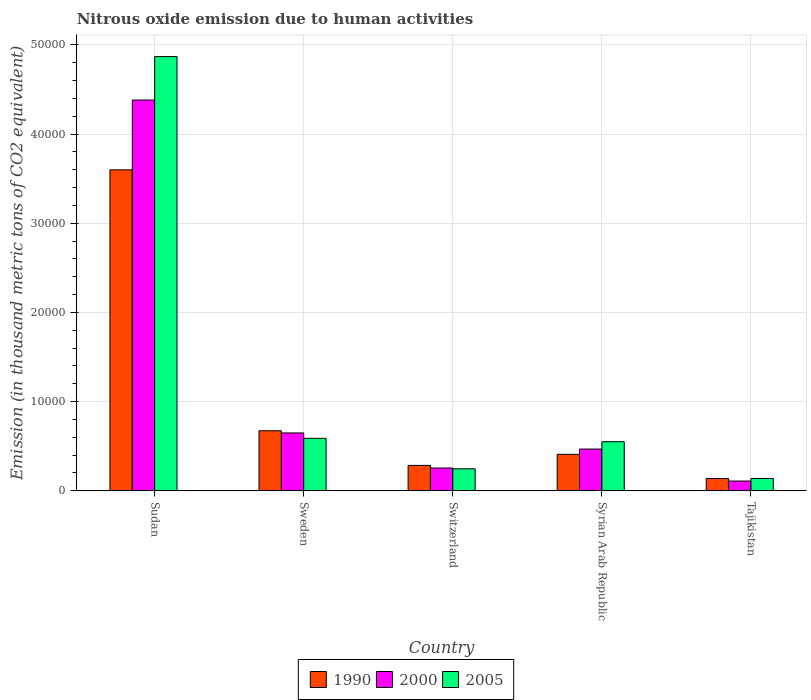Are the number of bars per tick equal to the number of legend labels?
Give a very brief answer. Yes. How many bars are there on the 4th tick from the left?
Offer a terse response. 3. What is the label of the 4th group of bars from the left?
Ensure brevity in your answer.  Syrian Arab Republic. What is the amount of nitrous oxide emitted in 2000 in Sweden?
Provide a short and direct response. 6484.9. Across all countries, what is the maximum amount of nitrous oxide emitted in 2000?
Offer a terse response. 4.38e+04. Across all countries, what is the minimum amount of nitrous oxide emitted in 2005?
Provide a succinct answer. 1381.6. In which country was the amount of nitrous oxide emitted in 2005 maximum?
Give a very brief answer. Sudan. In which country was the amount of nitrous oxide emitted in 1990 minimum?
Provide a succinct answer. Tajikistan. What is the total amount of nitrous oxide emitted in 1990 in the graph?
Your answer should be compact. 5.10e+04. What is the difference between the amount of nitrous oxide emitted in 1990 in Sudan and that in Tajikistan?
Offer a terse response. 3.46e+04. What is the difference between the amount of nitrous oxide emitted in 2000 in Syrian Arab Republic and the amount of nitrous oxide emitted in 1990 in Switzerland?
Ensure brevity in your answer.  1830.9. What is the average amount of nitrous oxide emitted in 1990 per country?
Ensure brevity in your answer.  1.02e+04. What is the difference between the amount of nitrous oxide emitted of/in 2000 and amount of nitrous oxide emitted of/in 1990 in Syrian Arab Republic?
Provide a succinct answer. 592.5. In how many countries, is the amount of nitrous oxide emitted in 2000 greater than 16000 thousand metric tons?
Provide a short and direct response. 1. What is the ratio of the amount of nitrous oxide emitted in 1990 in Sudan to that in Switzerland?
Your answer should be very brief. 12.64. What is the difference between the highest and the second highest amount of nitrous oxide emitted in 2005?
Keep it short and to the point. -4.28e+04. What is the difference between the highest and the lowest amount of nitrous oxide emitted in 2000?
Provide a short and direct response. 4.27e+04. Is the sum of the amount of nitrous oxide emitted in 1990 in Sweden and Syrian Arab Republic greater than the maximum amount of nitrous oxide emitted in 2000 across all countries?
Ensure brevity in your answer.  No. What does the 3rd bar from the left in Switzerland represents?
Give a very brief answer. 2005. Is it the case that in every country, the sum of the amount of nitrous oxide emitted in 1990 and amount of nitrous oxide emitted in 2005 is greater than the amount of nitrous oxide emitted in 2000?
Make the answer very short. Yes. How many bars are there?
Provide a short and direct response. 15. Are all the bars in the graph horizontal?
Offer a very short reply. No. What is the difference between two consecutive major ticks on the Y-axis?
Offer a very short reply. 10000. Does the graph contain any zero values?
Make the answer very short. No. Where does the legend appear in the graph?
Give a very brief answer. Bottom center. What is the title of the graph?
Ensure brevity in your answer.  Nitrous oxide emission due to human activities. Does "1978" appear as one of the legend labels in the graph?
Make the answer very short. No. What is the label or title of the Y-axis?
Ensure brevity in your answer.  Emission (in thousand metric tons of CO2 equivalent). What is the Emission (in thousand metric tons of CO2 equivalent) of 1990 in Sudan?
Your response must be concise. 3.60e+04. What is the Emission (in thousand metric tons of CO2 equivalent) of 2000 in Sudan?
Give a very brief answer. 4.38e+04. What is the Emission (in thousand metric tons of CO2 equivalent) of 2005 in Sudan?
Make the answer very short. 4.87e+04. What is the Emission (in thousand metric tons of CO2 equivalent) of 1990 in Sweden?
Give a very brief answer. 6731.4. What is the Emission (in thousand metric tons of CO2 equivalent) in 2000 in Sweden?
Offer a very short reply. 6484.9. What is the Emission (in thousand metric tons of CO2 equivalent) in 2005 in Sweden?
Ensure brevity in your answer.  5882.7. What is the Emission (in thousand metric tons of CO2 equivalent) of 1990 in Switzerland?
Give a very brief answer. 2846.4. What is the Emission (in thousand metric tons of CO2 equivalent) of 2000 in Switzerland?
Offer a very short reply. 2551.9. What is the Emission (in thousand metric tons of CO2 equivalent) in 2005 in Switzerland?
Your answer should be compact. 2463.6. What is the Emission (in thousand metric tons of CO2 equivalent) in 1990 in Syrian Arab Republic?
Ensure brevity in your answer.  4084.8. What is the Emission (in thousand metric tons of CO2 equivalent) in 2000 in Syrian Arab Republic?
Ensure brevity in your answer.  4677.3. What is the Emission (in thousand metric tons of CO2 equivalent) in 2005 in Syrian Arab Republic?
Your response must be concise. 5502.2. What is the Emission (in thousand metric tons of CO2 equivalent) of 1990 in Tajikistan?
Ensure brevity in your answer.  1377.2. What is the Emission (in thousand metric tons of CO2 equivalent) of 2000 in Tajikistan?
Provide a short and direct response. 1092.8. What is the Emission (in thousand metric tons of CO2 equivalent) in 2005 in Tajikistan?
Offer a terse response. 1381.6. Across all countries, what is the maximum Emission (in thousand metric tons of CO2 equivalent) in 1990?
Make the answer very short. 3.60e+04. Across all countries, what is the maximum Emission (in thousand metric tons of CO2 equivalent) of 2000?
Offer a very short reply. 4.38e+04. Across all countries, what is the maximum Emission (in thousand metric tons of CO2 equivalent) of 2005?
Your answer should be compact. 4.87e+04. Across all countries, what is the minimum Emission (in thousand metric tons of CO2 equivalent) of 1990?
Provide a succinct answer. 1377.2. Across all countries, what is the minimum Emission (in thousand metric tons of CO2 equivalent) of 2000?
Ensure brevity in your answer.  1092.8. Across all countries, what is the minimum Emission (in thousand metric tons of CO2 equivalent) in 2005?
Keep it short and to the point. 1381.6. What is the total Emission (in thousand metric tons of CO2 equivalent) in 1990 in the graph?
Ensure brevity in your answer.  5.10e+04. What is the total Emission (in thousand metric tons of CO2 equivalent) of 2000 in the graph?
Your answer should be very brief. 5.86e+04. What is the total Emission (in thousand metric tons of CO2 equivalent) in 2005 in the graph?
Offer a terse response. 6.39e+04. What is the difference between the Emission (in thousand metric tons of CO2 equivalent) in 1990 in Sudan and that in Sweden?
Offer a very short reply. 2.93e+04. What is the difference between the Emission (in thousand metric tons of CO2 equivalent) in 2000 in Sudan and that in Sweden?
Your response must be concise. 3.73e+04. What is the difference between the Emission (in thousand metric tons of CO2 equivalent) of 2005 in Sudan and that in Sweden?
Offer a very short reply. 4.28e+04. What is the difference between the Emission (in thousand metric tons of CO2 equivalent) of 1990 in Sudan and that in Switzerland?
Provide a succinct answer. 3.31e+04. What is the difference between the Emission (in thousand metric tons of CO2 equivalent) in 2000 in Sudan and that in Switzerland?
Offer a very short reply. 4.13e+04. What is the difference between the Emission (in thousand metric tons of CO2 equivalent) of 2005 in Sudan and that in Switzerland?
Keep it short and to the point. 4.62e+04. What is the difference between the Emission (in thousand metric tons of CO2 equivalent) of 1990 in Sudan and that in Syrian Arab Republic?
Keep it short and to the point. 3.19e+04. What is the difference between the Emission (in thousand metric tons of CO2 equivalent) of 2000 in Sudan and that in Syrian Arab Republic?
Give a very brief answer. 3.91e+04. What is the difference between the Emission (in thousand metric tons of CO2 equivalent) of 2005 in Sudan and that in Syrian Arab Republic?
Make the answer very short. 4.32e+04. What is the difference between the Emission (in thousand metric tons of CO2 equivalent) in 1990 in Sudan and that in Tajikistan?
Ensure brevity in your answer.  3.46e+04. What is the difference between the Emission (in thousand metric tons of CO2 equivalent) in 2000 in Sudan and that in Tajikistan?
Ensure brevity in your answer.  4.27e+04. What is the difference between the Emission (in thousand metric tons of CO2 equivalent) in 2005 in Sudan and that in Tajikistan?
Provide a succinct answer. 4.73e+04. What is the difference between the Emission (in thousand metric tons of CO2 equivalent) of 1990 in Sweden and that in Switzerland?
Your answer should be very brief. 3885. What is the difference between the Emission (in thousand metric tons of CO2 equivalent) of 2000 in Sweden and that in Switzerland?
Give a very brief answer. 3933. What is the difference between the Emission (in thousand metric tons of CO2 equivalent) of 2005 in Sweden and that in Switzerland?
Your answer should be very brief. 3419.1. What is the difference between the Emission (in thousand metric tons of CO2 equivalent) in 1990 in Sweden and that in Syrian Arab Republic?
Provide a short and direct response. 2646.6. What is the difference between the Emission (in thousand metric tons of CO2 equivalent) in 2000 in Sweden and that in Syrian Arab Republic?
Provide a succinct answer. 1807.6. What is the difference between the Emission (in thousand metric tons of CO2 equivalent) in 2005 in Sweden and that in Syrian Arab Republic?
Offer a very short reply. 380.5. What is the difference between the Emission (in thousand metric tons of CO2 equivalent) in 1990 in Sweden and that in Tajikistan?
Keep it short and to the point. 5354.2. What is the difference between the Emission (in thousand metric tons of CO2 equivalent) of 2000 in Sweden and that in Tajikistan?
Offer a terse response. 5392.1. What is the difference between the Emission (in thousand metric tons of CO2 equivalent) in 2005 in Sweden and that in Tajikistan?
Make the answer very short. 4501.1. What is the difference between the Emission (in thousand metric tons of CO2 equivalent) of 1990 in Switzerland and that in Syrian Arab Republic?
Offer a terse response. -1238.4. What is the difference between the Emission (in thousand metric tons of CO2 equivalent) in 2000 in Switzerland and that in Syrian Arab Republic?
Give a very brief answer. -2125.4. What is the difference between the Emission (in thousand metric tons of CO2 equivalent) of 2005 in Switzerland and that in Syrian Arab Republic?
Give a very brief answer. -3038.6. What is the difference between the Emission (in thousand metric tons of CO2 equivalent) in 1990 in Switzerland and that in Tajikistan?
Give a very brief answer. 1469.2. What is the difference between the Emission (in thousand metric tons of CO2 equivalent) of 2000 in Switzerland and that in Tajikistan?
Your answer should be very brief. 1459.1. What is the difference between the Emission (in thousand metric tons of CO2 equivalent) in 2005 in Switzerland and that in Tajikistan?
Provide a succinct answer. 1082. What is the difference between the Emission (in thousand metric tons of CO2 equivalent) in 1990 in Syrian Arab Republic and that in Tajikistan?
Your answer should be compact. 2707.6. What is the difference between the Emission (in thousand metric tons of CO2 equivalent) of 2000 in Syrian Arab Republic and that in Tajikistan?
Offer a very short reply. 3584.5. What is the difference between the Emission (in thousand metric tons of CO2 equivalent) in 2005 in Syrian Arab Republic and that in Tajikistan?
Ensure brevity in your answer.  4120.6. What is the difference between the Emission (in thousand metric tons of CO2 equivalent) in 1990 in Sudan and the Emission (in thousand metric tons of CO2 equivalent) in 2000 in Sweden?
Provide a short and direct response. 2.95e+04. What is the difference between the Emission (in thousand metric tons of CO2 equivalent) in 1990 in Sudan and the Emission (in thousand metric tons of CO2 equivalent) in 2005 in Sweden?
Make the answer very short. 3.01e+04. What is the difference between the Emission (in thousand metric tons of CO2 equivalent) of 2000 in Sudan and the Emission (in thousand metric tons of CO2 equivalent) of 2005 in Sweden?
Make the answer very short. 3.79e+04. What is the difference between the Emission (in thousand metric tons of CO2 equivalent) of 1990 in Sudan and the Emission (in thousand metric tons of CO2 equivalent) of 2000 in Switzerland?
Provide a short and direct response. 3.34e+04. What is the difference between the Emission (in thousand metric tons of CO2 equivalent) in 1990 in Sudan and the Emission (in thousand metric tons of CO2 equivalent) in 2005 in Switzerland?
Give a very brief answer. 3.35e+04. What is the difference between the Emission (in thousand metric tons of CO2 equivalent) of 2000 in Sudan and the Emission (in thousand metric tons of CO2 equivalent) of 2005 in Switzerland?
Your answer should be compact. 4.13e+04. What is the difference between the Emission (in thousand metric tons of CO2 equivalent) in 1990 in Sudan and the Emission (in thousand metric tons of CO2 equivalent) in 2000 in Syrian Arab Republic?
Offer a terse response. 3.13e+04. What is the difference between the Emission (in thousand metric tons of CO2 equivalent) in 1990 in Sudan and the Emission (in thousand metric tons of CO2 equivalent) in 2005 in Syrian Arab Republic?
Your answer should be compact. 3.05e+04. What is the difference between the Emission (in thousand metric tons of CO2 equivalent) of 2000 in Sudan and the Emission (in thousand metric tons of CO2 equivalent) of 2005 in Syrian Arab Republic?
Offer a very short reply. 3.83e+04. What is the difference between the Emission (in thousand metric tons of CO2 equivalent) of 1990 in Sudan and the Emission (in thousand metric tons of CO2 equivalent) of 2000 in Tajikistan?
Make the answer very short. 3.49e+04. What is the difference between the Emission (in thousand metric tons of CO2 equivalent) in 1990 in Sudan and the Emission (in thousand metric tons of CO2 equivalent) in 2005 in Tajikistan?
Give a very brief answer. 3.46e+04. What is the difference between the Emission (in thousand metric tons of CO2 equivalent) in 2000 in Sudan and the Emission (in thousand metric tons of CO2 equivalent) in 2005 in Tajikistan?
Your answer should be compact. 4.24e+04. What is the difference between the Emission (in thousand metric tons of CO2 equivalent) in 1990 in Sweden and the Emission (in thousand metric tons of CO2 equivalent) in 2000 in Switzerland?
Keep it short and to the point. 4179.5. What is the difference between the Emission (in thousand metric tons of CO2 equivalent) of 1990 in Sweden and the Emission (in thousand metric tons of CO2 equivalent) of 2005 in Switzerland?
Your response must be concise. 4267.8. What is the difference between the Emission (in thousand metric tons of CO2 equivalent) of 2000 in Sweden and the Emission (in thousand metric tons of CO2 equivalent) of 2005 in Switzerland?
Offer a very short reply. 4021.3. What is the difference between the Emission (in thousand metric tons of CO2 equivalent) in 1990 in Sweden and the Emission (in thousand metric tons of CO2 equivalent) in 2000 in Syrian Arab Republic?
Provide a short and direct response. 2054.1. What is the difference between the Emission (in thousand metric tons of CO2 equivalent) in 1990 in Sweden and the Emission (in thousand metric tons of CO2 equivalent) in 2005 in Syrian Arab Republic?
Your answer should be very brief. 1229.2. What is the difference between the Emission (in thousand metric tons of CO2 equivalent) in 2000 in Sweden and the Emission (in thousand metric tons of CO2 equivalent) in 2005 in Syrian Arab Republic?
Keep it short and to the point. 982.7. What is the difference between the Emission (in thousand metric tons of CO2 equivalent) in 1990 in Sweden and the Emission (in thousand metric tons of CO2 equivalent) in 2000 in Tajikistan?
Keep it short and to the point. 5638.6. What is the difference between the Emission (in thousand metric tons of CO2 equivalent) in 1990 in Sweden and the Emission (in thousand metric tons of CO2 equivalent) in 2005 in Tajikistan?
Your answer should be compact. 5349.8. What is the difference between the Emission (in thousand metric tons of CO2 equivalent) in 2000 in Sweden and the Emission (in thousand metric tons of CO2 equivalent) in 2005 in Tajikistan?
Your answer should be compact. 5103.3. What is the difference between the Emission (in thousand metric tons of CO2 equivalent) in 1990 in Switzerland and the Emission (in thousand metric tons of CO2 equivalent) in 2000 in Syrian Arab Republic?
Ensure brevity in your answer.  -1830.9. What is the difference between the Emission (in thousand metric tons of CO2 equivalent) in 1990 in Switzerland and the Emission (in thousand metric tons of CO2 equivalent) in 2005 in Syrian Arab Republic?
Your response must be concise. -2655.8. What is the difference between the Emission (in thousand metric tons of CO2 equivalent) in 2000 in Switzerland and the Emission (in thousand metric tons of CO2 equivalent) in 2005 in Syrian Arab Republic?
Provide a short and direct response. -2950.3. What is the difference between the Emission (in thousand metric tons of CO2 equivalent) in 1990 in Switzerland and the Emission (in thousand metric tons of CO2 equivalent) in 2000 in Tajikistan?
Your answer should be compact. 1753.6. What is the difference between the Emission (in thousand metric tons of CO2 equivalent) in 1990 in Switzerland and the Emission (in thousand metric tons of CO2 equivalent) in 2005 in Tajikistan?
Provide a short and direct response. 1464.8. What is the difference between the Emission (in thousand metric tons of CO2 equivalent) of 2000 in Switzerland and the Emission (in thousand metric tons of CO2 equivalent) of 2005 in Tajikistan?
Keep it short and to the point. 1170.3. What is the difference between the Emission (in thousand metric tons of CO2 equivalent) in 1990 in Syrian Arab Republic and the Emission (in thousand metric tons of CO2 equivalent) in 2000 in Tajikistan?
Offer a terse response. 2992. What is the difference between the Emission (in thousand metric tons of CO2 equivalent) of 1990 in Syrian Arab Republic and the Emission (in thousand metric tons of CO2 equivalent) of 2005 in Tajikistan?
Your answer should be compact. 2703.2. What is the difference between the Emission (in thousand metric tons of CO2 equivalent) in 2000 in Syrian Arab Republic and the Emission (in thousand metric tons of CO2 equivalent) in 2005 in Tajikistan?
Offer a terse response. 3295.7. What is the average Emission (in thousand metric tons of CO2 equivalent) in 1990 per country?
Your response must be concise. 1.02e+04. What is the average Emission (in thousand metric tons of CO2 equivalent) of 2000 per country?
Provide a succinct answer. 1.17e+04. What is the average Emission (in thousand metric tons of CO2 equivalent) in 2005 per country?
Give a very brief answer. 1.28e+04. What is the difference between the Emission (in thousand metric tons of CO2 equivalent) of 1990 and Emission (in thousand metric tons of CO2 equivalent) of 2000 in Sudan?
Provide a short and direct response. -7827.3. What is the difference between the Emission (in thousand metric tons of CO2 equivalent) of 1990 and Emission (in thousand metric tons of CO2 equivalent) of 2005 in Sudan?
Your answer should be compact. -1.27e+04. What is the difference between the Emission (in thousand metric tons of CO2 equivalent) of 2000 and Emission (in thousand metric tons of CO2 equivalent) of 2005 in Sudan?
Your answer should be very brief. -4871.9. What is the difference between the Emission (in thousand metric tons of CO2 equivalent) in 1990 and Emission (in thousand metric tons of CO2 equivalent) in 2000 in Sweden?
Ensure brevity in your answer.  246.5. What is the difference between the Emission (in thousand metric tons of CO2 equivalent) of 1990 and Emission (in thousand metric tons of CO2 equivalent) of 2005 in Sweden?
Give a very brief answer. 848.7. What is the difference between the Emission (in thousand metric tons of CO2 equivalent) in 2000 and Emission (in thousand metric tons of CO2 equivalent) in 2005 in Sweden?
Offer a very short reply. 602.2. What is the difference between the Emission (in thousand metric tons of CO2 equivalent) of 1990 and Emission (in thousand metric tons of CO2 equivalent) of 2000 in Switzerland?
Ensure brevity in your answer.  294.5. What is the difference between the Emission (in thousand metric tons of CO2 equivalent) of 1990 and Emission (in thousand metric tons of CO2 equivalent) of 2005 in Switzerland?
Make the answer very short. 382.8. What is the difference between the Emission (in thousand metric tons of CO2 equivalent) in 2000 and Emission (in thousand metric tons of CO2 equivalent) in 2005 in Switzerland?
Keep it short and to the point. 88.3. What is the difference between the Emission (in thousand metric tons of CO2 equivalent) in 1990 and Emission (in thousand metric tons of CO2 equivalent) in 2000 in Syrian Arab Republic?
Your answer should be compact. -592.5. What is the difference between the Emission (in thousand metric tons of CO2 equivalent) in 1990 and Emission (in thousand metric tons of CO2 equivalent) in 2005 in Syrian Arab Republic?
Keep it short and to the point. -1417.4. What is the difference between the Emission (in thousand metric tons of CO2 equivalent) of 2000 and Emission (in thousand metric tons of CO2 equivalent) of 2005 in Syrian Arab Republic?
Give a very brief answer. -824.9. What is the difference between the Emission (in thousand metric tons of CO2 equivalent) in 1990 and Emission (in thousand metric tons of CO2 equivalent) in 2000 in Tajikistan?
Offer a terse response. 284.4. What is the difference between the Emission (in thousand metric tons of CO2 equivalent) in 1990 and Emission (in thousand metric tons of CO2 equivalent) in 2005 in Tajikistan?
Your answer should be very brief. -4.4. What is the difference between the Emission (in thousand metric tons of CO2 equivalent) in 2000 and Emission (in thousand metric tons of CO2 equivalent) in 2005 in Tajikistan?
Your response must be concise. -288.8. What is the ratio of the Emission (in thousand metric tons of CO2 equivalent) in 1990 in Sudan to that in Sweden?
Make the answer very short. 5.35. What is the ratio of the Emission (in thousand metric tons of CO2 equivalent) of 2000 in Sudan to that in Sweden?
Your answer should be compact. 6.76. What is the ratio of the Emission (in thousand metric tons of CO2 equivalent) of 2005 in Sudan to that in Sweden?
Provide a succinct answer. 8.28. What is the ratio of the Emission (in thousand metric tons of CO2 equivalent) in 1990 in Sudan to that in Switzerland?
Provide a short and direct response. 12.64. What is the ratio of the Emission (in thousand metric tons of CO2 equivalent) in 2000 in Sudan to that in Switzerland?
Make the answer very short. 17.17. What is the ratio of the Emission (in thousand metric tons of CO2 equivalent) of 2005 in Sudan to that in Switzerland?
Keep it short and to the point. 19.76. What is the ratio of the Emission (in thousand metric tons of CO2 equivalent) of 1990 in Sudan to that in Syrian Arab Republic?
Offer a terse response. 8.81. What is the ratio of the Emission (in thousand metric tons of CO2 equivalent) of 2000 in Sudan to that in Syrian Arab Republic?
Make the answer very short. 9.37. What is the ratio of the Emission (in thousand metric tons of CO2 equivalent) of 2005 in Sudan to that in Syrian Arab Republic?
Offer a terse response. 8.85. What is the ratio of the Emission (in thousand metric tons of CO2 equivalent) in 1990 in Sudan to that in Tajikistan?
Keep it short and to the point. 26.13. What is the ratio of the Emission (in thousand metric tons of CO2 equivalent) in 2000 in Sudan to that in Tajikistan?
Provide a succinct answer. 40.09. What is the ratio of the Emission (in thousand metric tons of CO2 equivalent) of 2005 in Sudan to that in Tajikistan?
Ensure brevity in your answer.  35.24. What is the ratio of the Emission (in thousand metric tons of CO2 equivalent) of 1990 in Sweden to that in Switzerland?
Provide a succinct answer. 2.36. What is the ratio of the Emission (in thousand metric tons of CO2 equivalent) in 2000 in Sweden to that in Switzerland?
Your response must be concise. 2.54. What is the ratio of the Emission (in thousand metric tons of CO2 equivalent) of 2005 in Sweden to that in Switzerland?
Provide a succinct answer. 2.39. What is the ratio of the Emission (in thousand metric tons of CO2 equivalent) of 1990 in Sweden to that in Syrian Arab Republic?
Your answer should be compact. 1.65. What is the ratio of the Emission (in thousand metric tons of CO2 equivalent) of 2000 in Sweden to that in Syrian Arab Republic?
Offer a very short reply. 1.39. What is the ratio of the Emission (in thousand metric tons of CO2 equivalent) of 2005 in Sweden to that in Syrian Arab Republic?
Keep it short and to the point. 1.07. What is the ratio of the Emission (in thousand metric tons of CO2 equivalent) in 1990 in Sweden to that in Tajikistan?
Keep it short and to the point. 4.89. What is the ratio of the Emission (in thousand metric tons of CO2 equivalent) in 2000 in Sweden to that in Tajikistan?
Your answer should be compact. 5.93. What is the ratio of the Emission (in thousand metric tons of CO2 equivalent) of 2005 in Sweden to that in Tajikistan?
Offer a terse response. 4.26. What is the ratio of the Emission (in thousand metric tons of CO2 equivalent) of 1990 in Switzerland to that in Syrian Arab Republic?
Offer a terse response. 0.7. What is the ratio of the Emission (in thousand metric tons of CO2 equivalent) of 2000 in Switzerland to that in Syrian Arab Republic?
Keep it short and to the point. 0.55. What is the ratio of the Emission (in thousand metric tons of CO2 equivalent) in 2005 in Switzerland to that in Syrian Arab Republic?
Keep it short and to the point. 0.45. What is the ratio of the Emission (in thousand metric tons of CO2 equivalent) in 1990 in Switzerland to that in Tajikistan?
Ensure brevity in your answer.  2.07. What is the ratio of the Emission (in thousand metric tons of CO2 equivalent) of 2000 in Switzerland to that in Tajikistan?
Make the answer very short. 2.34. What is the ratio of the Emission (in thousand metric tons of CO2 equivalent) of 2005 in Switzerland to that in Tajikistan?
Make the answer very short. 1.78. What is the ratio of the Emission (in thousand metric tons of CO2 equivalent) in 1990 in Syrian Arab Republic to that in Tajikistan?
Provide a succinct answer. 2.97. What is the ratio of the Emission (in thousand metric tons of CO2 equivalent) of 2000 in Syrian Arab Republic to that in Tajikistan?
Your answer should be compact. 4.28. What is the ratio of the Emission (in thousand metric tons of CO2 equivalent) of 2005 in Syrian Arab Republic to that in Tajikistan?
Your response must be concise. 3.98. What is the difference between the highest and the second highest Emission (in thousand metric tons of CO2 equivalent) of 1990?
Your answer should be compact. 2.93e+04. What is the difference between the highest and the second highest Emission (in thousand metric tons of CO2 equivalent) in 2000?
Make the answer very short. 3.73e+04. What is the difference between the highest and the second highest Emission (in thousand metric tons of CO2 equivalent) in 2005?
Your answer should be very brief. 4.28e+04. What is the difference between the highest and the lowest Emission (in thousand metric tons of CO2 equivalent) in 1990?
Your answer should be very brief. 3.46e+04. What is the difference between the highest and the lowest Emission (in thousand metric tons of CO2 equivalent) in 2000?
Ensure brevity in your answer.  4.27e+04. What is the difference between the highest and the lowest Emission (in thousand metric tons of CO2 equivalent) in 2005?
Ensure brevity in your answer.  4.73e+04. 